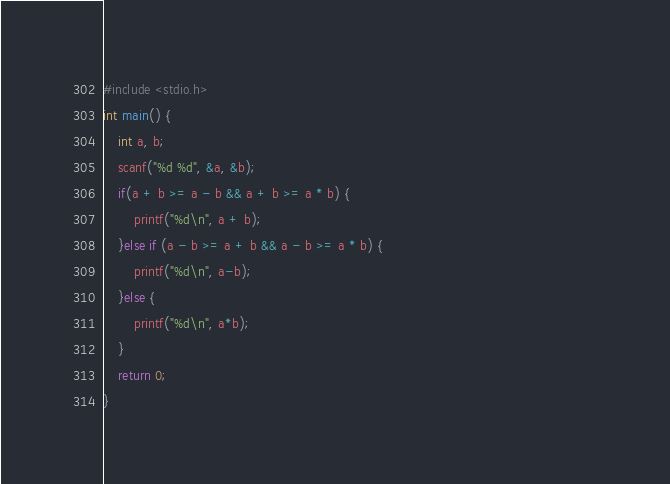<code> <loc_0><loc_0><loc_500><loc_500><_C_>#include <stdio.h>                                                                                       
int main() {                                                                                             
    int a, b;                                                                                            
    scanf("%d %d", &a, &b);                                                                              
    if(a + b >= a - b && a + b >= a * b) {                                                               
        printf("%d\n", a + b);                                                                           
    }else if (a - b >= a + b && a - b >= a * b) {                                                        
        printf("%d\n", a-b);                                                                             
    }else {                                                                                              
        printf("%d\n", a*b);                                                                             
    }                                                                                                    
    return 0;                                                                                            
}      </code> 